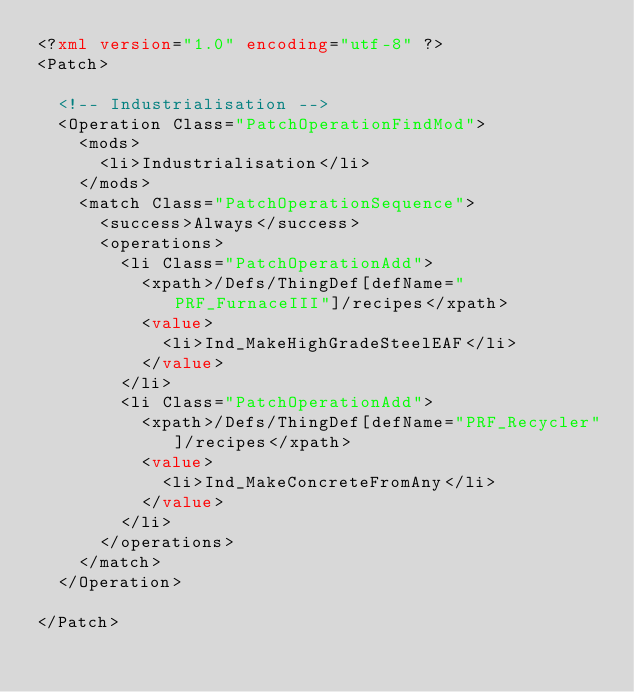<code> <loc_0><loc_0><loc_500><loc_500><_XML_><?xml version="1.0" encoding="utf-8" ?>
<Patch>

	<!-- Industrialisation -->
	<Operation Class="PatchOperationFindMod">
		<mods>
			<li>Industrialisation</li>
		</mods>
		<match Class="PatchOperationSequence">
			<success>Always</success>
			<operations>
				<li Class="PatchOperationAdd">
					<xpath>/Defs/ThingDef[defName="PRF_FurnaceIII"]/recipes</xpath>
					<value>
						<li>Ind_MakeHighGradeSteelEAF</li>
					</value>
				</li>
				<li Class="PatchOperationAdd">
					<xpath>/Defs/ThingDef[defName="PRF_Recycler"]/recipes</xpath>
					<value>
						<li>Ind_MakeConcreteFromAny</li>
					</value>
				</li>
			</operations>
		</match>
	</Operation>

</Patch></code> 